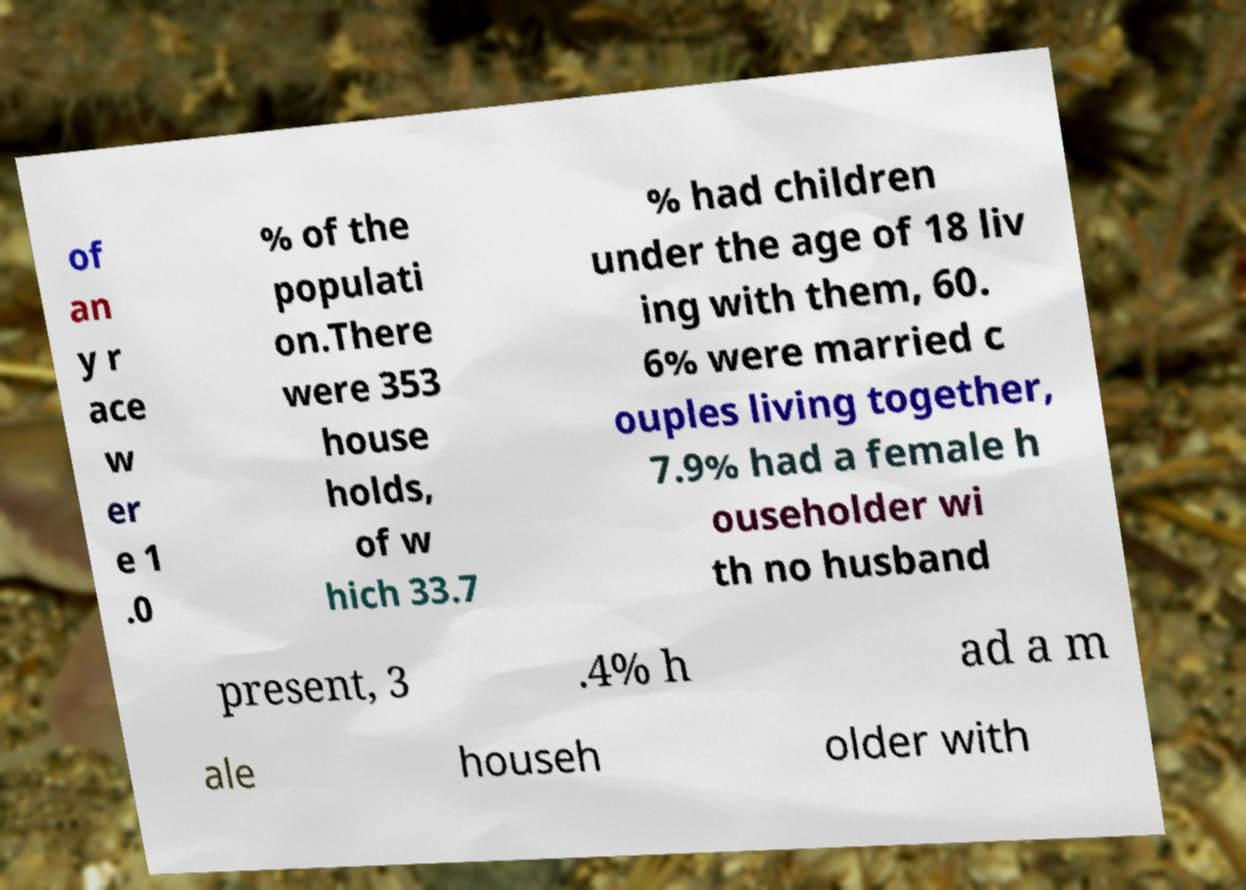Could you extract and type out the text from this image? of an y r ace w er e 1 .0 % of the populati on.There were 353 house holds, of w hich 33.7 % had children under the age of 18 liv ing with them, 60. 6% were married c ouples living together, 7.9% had a female h ouseholder wi th no husband present, 3 .4% h ad a m ale househ older with 